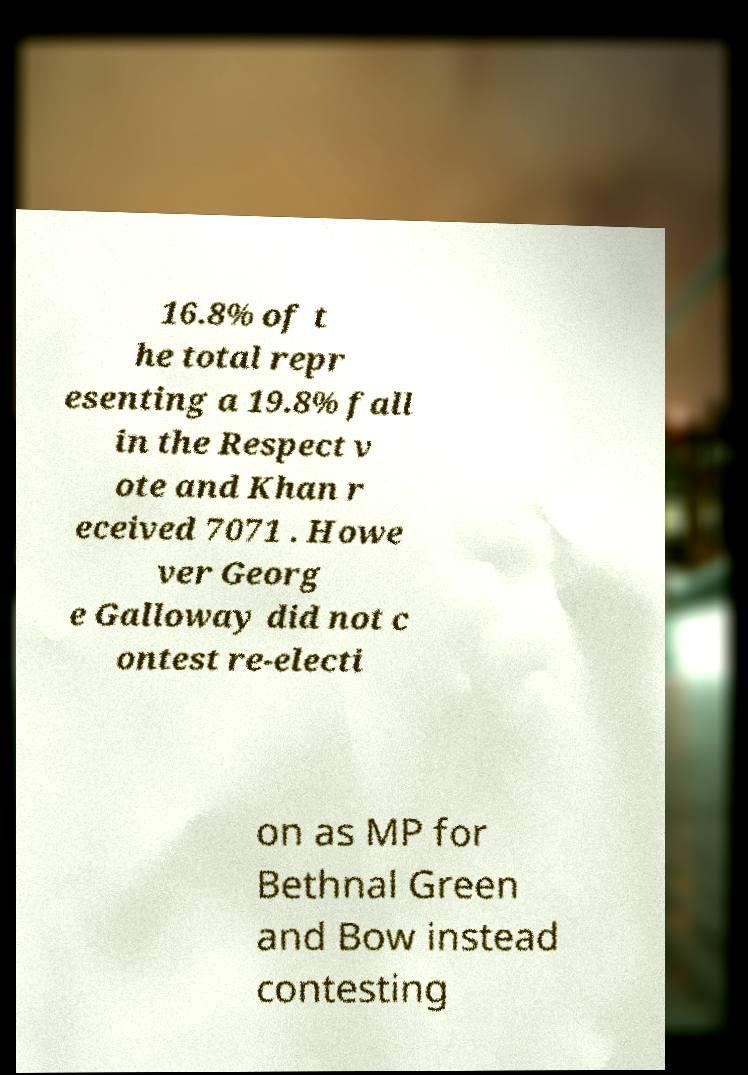I need the written content from this picture converted into text. Can you do that? 16.8% of t he total repr esenting a 19.8% fall in the Respect v ote and Khan r eceived 7071 . Howe ver Georg e Galloway did not c ontest re-electi on as MP for Bethnal Green and Bow instead contesting 